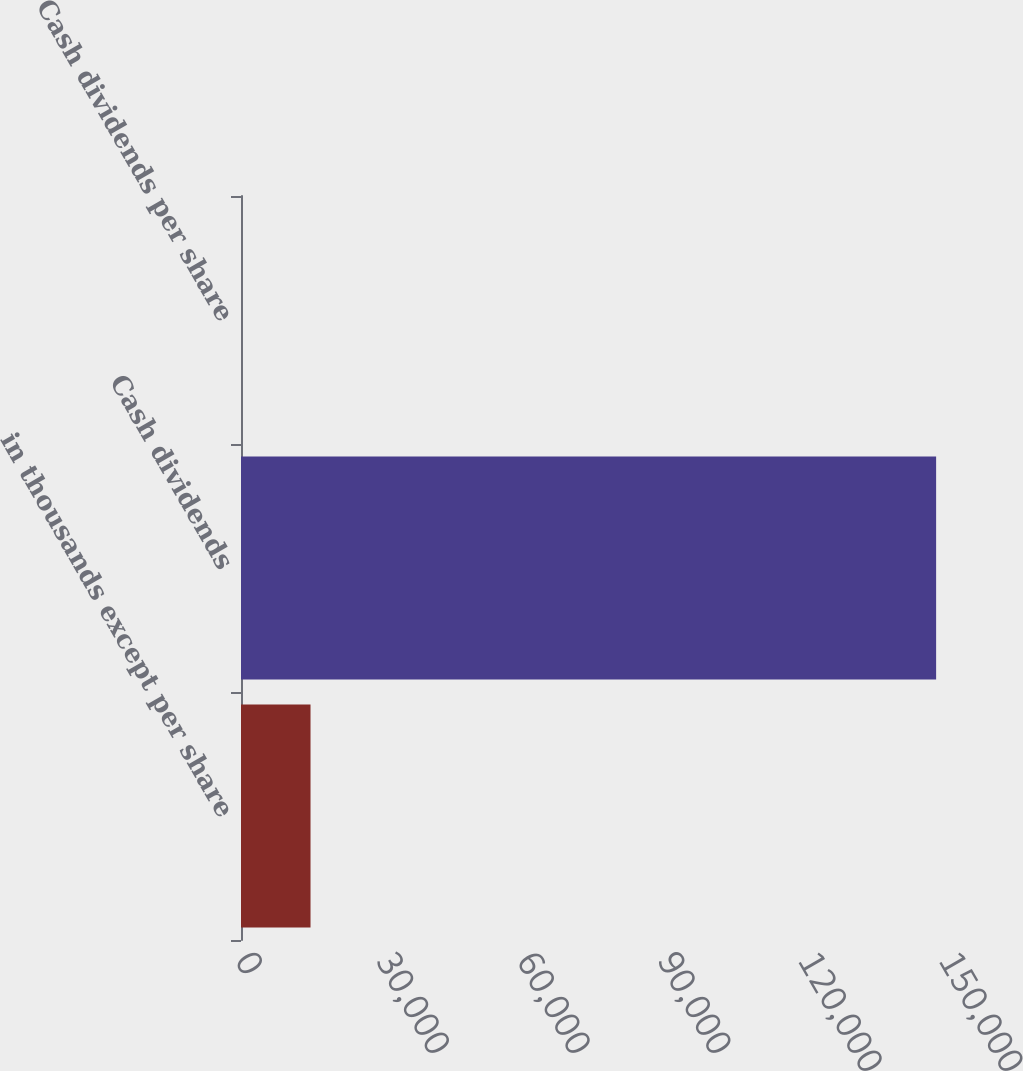Convert chart. <chart><loc_0><loc_0><loc_500><loc_500><bar_chart><fcel>in thousands except per share<fcel>Cash dividends<fcel>Cash dividends per share<nl><fcel>14811.9<fcel>148109<fcel>1.12<nl></chart> 